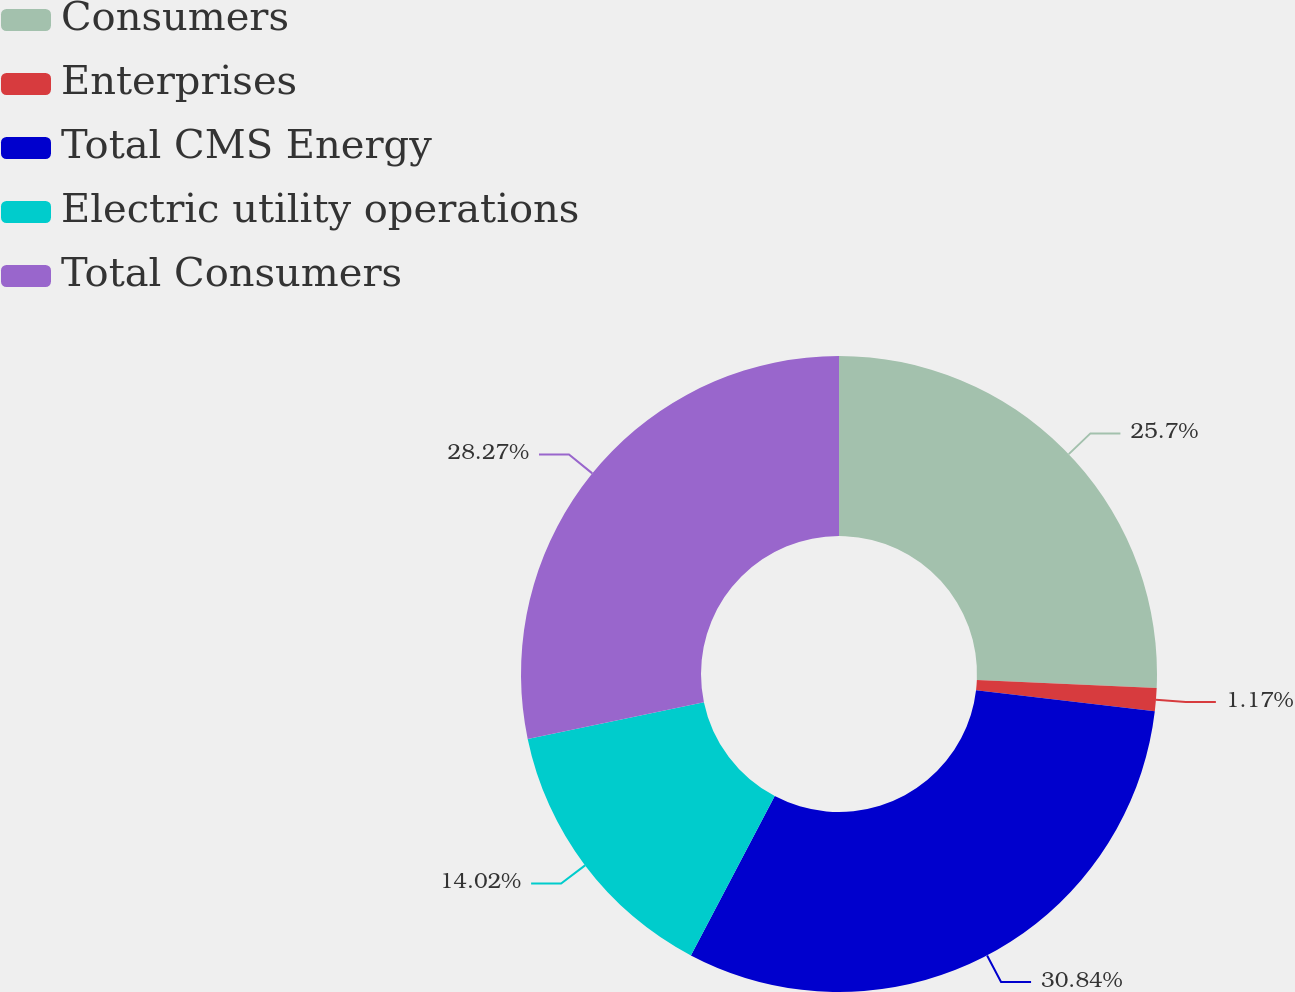<chart> <loc_0><loc_0><loc_500><loc_500><pie_chart><fcel>Consumers<fcel>Enterprises<fcel>Total CMS Energy<fcel>Electric utility operations<fcel>Total Consumers<nl><fcel>25.7%<fcel>1.17%<fcel>30.84%<fcel>14.02%<fcel>28.27%<nl></chart> 